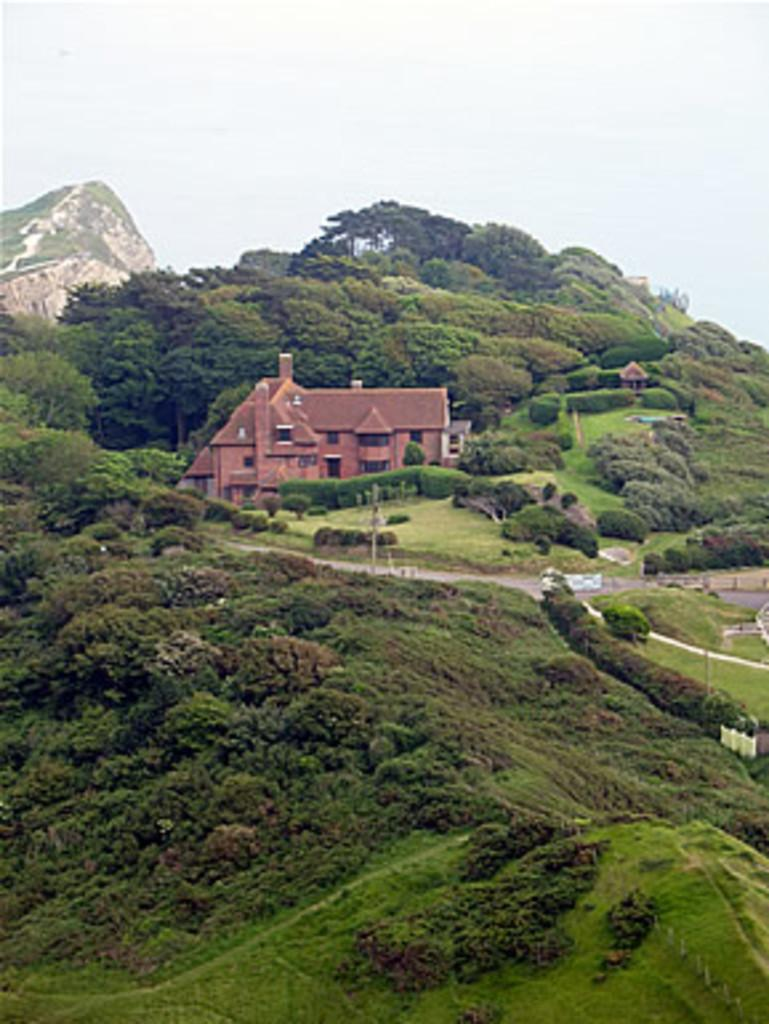What type of structure is present in the image? There is a house in the image. What type of vegetation can be seen in the image? There is grass, plants, and trees in the image. What natural feature is visible in the image? There is a mountain in the image. What part of the natural environment is visible in the background of the image? The sky is visible in the background of the image. Where is the harbor located in the image? There is no harbor present in the image. What type of pan is being used to cook in the image? There is no pan or cooking activity present in the image. 